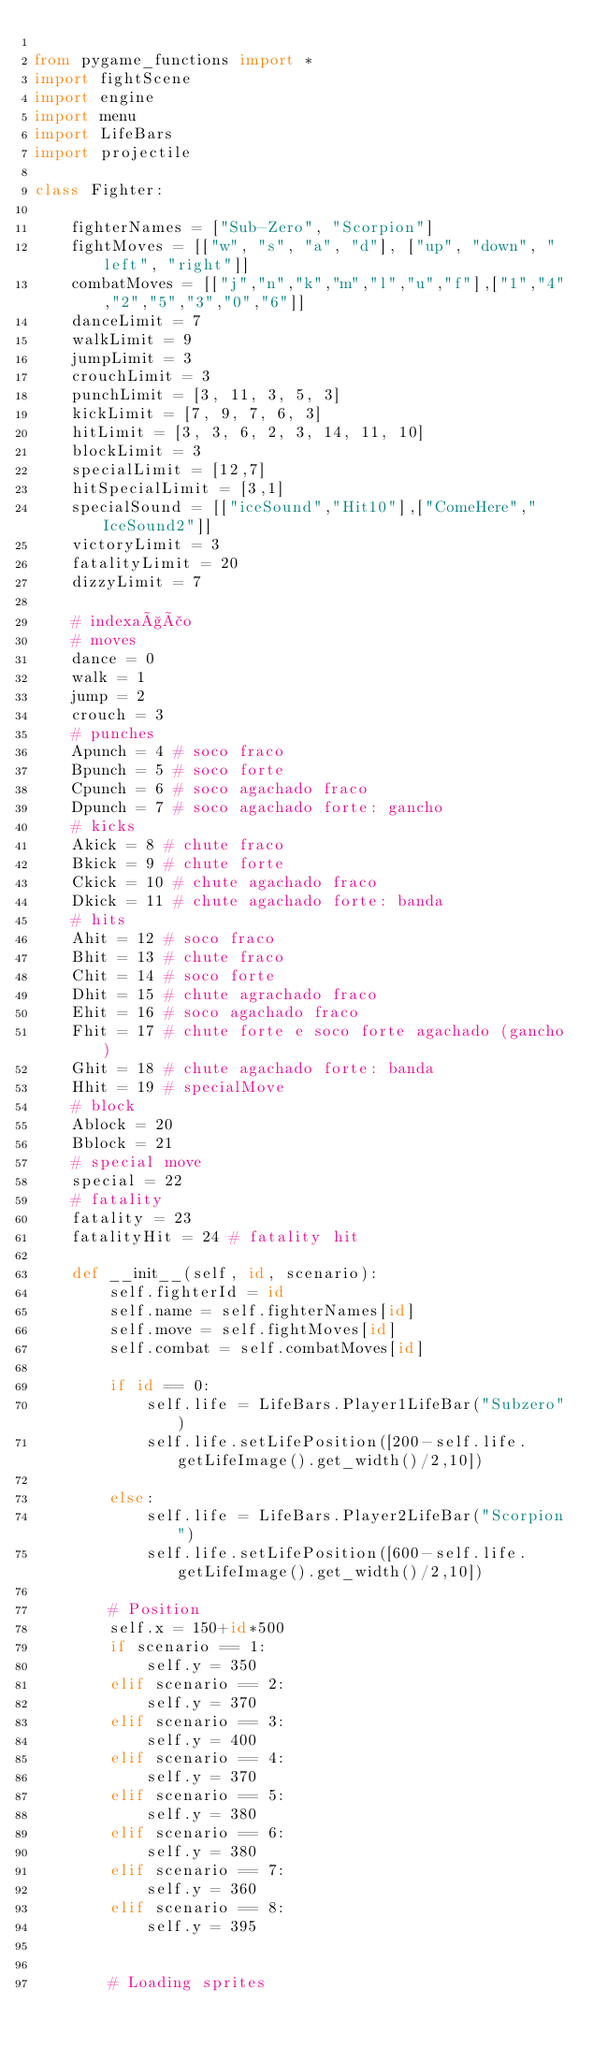Convert code to text. <code><loc_0><loc_0><loc_500><loc_500><_Python_>
from pygame_functions import *
import fightScene
import engine
import menu
import LifeBars
import projectile

class Fighter:

    fighterNames = ["Sub-Zero", "Scorpion"]
    fightMoves = [["w", "s", "a", "d"], ["up", "down", "left", "right"]]
    combatMoves = [["j","n","k","m","l","u","f"],["1","4","2","5","3","0","6"]]
    danceLimit = 7
    walkLimit = 9
    jumpLimit = 3
    crouchLimit = 3
    punchLimit = [3, 11, 3, 5, 3]
    kickLimit = [7, 9, 7, 6, 3]
    hitLimit = [3, 3, 6, 2, 3, 14, 11, 10]
    blockLimit = 3
    specialLimit = [12,7]
    hitSpecialLimit = [3,1]
    specialSound = [["iceSound","Hit10"],["ComeHere","IceSound2"]]
    victoryLimit = 3
    fatalityLimit = 20
    dizzyLimit = 7

    # indexação
    # moves
    dance = 0
    walk = 1
    jump = 2
    crouch = 3
    # punches
    Apunch = 4 # soco fraco
    Bpunch = 5 # soco forte
    Cpunch = 6 # soco agachado fraco
    Dpunch = 7 # soco agachado forte: gancho
    # kicks
    Akick = 8 # chute fraco
    Bkick = 9 # chute forte
    Ckick = 10 # chute agachado fraco
    Dkick = 11 # chute agachado forte: banda
    # hits
    Ahit = 12 # soco fraco
    Bhit = 13 # chute fraco
    Chit = 14 # soco forte
    Dhit = 15 # chute agrachado fraco
    Ehit = 16 # soco agachado fraco
    Fhit = 17 # chute forte e soco forte agachado (gancho)
    Ghit = 18 # chute agachado forte: banda
    Hhit = 19 # specialMove
    # block
    Ablock = 20
    Bblock = 21
    # special move
    special = 22
    # fatality
    fatality = 23 
    fatalityHit = 24 # fatality hit

    def __init__(self, id, scenario):
        self.fighterId = id
        self.name = self.fighterNames[id]
        self.move = self.fightMoves[id]
        self.combat = self.combatMoves[id] 

        if id == 0:
            self.life = LifeBars.Player1LifeBar("Subzero")
            self.life.setLifePosition([200-self.life.getLifeImage().get_width()/2,10])

        else:
            self.life = LifeBars.Player2LifeBar("Scorpion")
            self.life.setLifePosition([600-self.life.getLifeImage().get_width()/2,10])

        # Position
        self.x = 150+id*500
        if scenario == 1:
            self.y = 350
        elif scenario == 2:
            self.y = 370
        elif scenario == 3:
            self.y = 400
        elif scenario == 4:
            self.y = 370
        elif scenario == 5:
            self.y = 380
        elif scenario == 6:
            self.y = 380
        elif scenario == 7:
            self.y = 360
        elif scenario == 8:
            self.y = 395          


        # Loading sprites</code> 